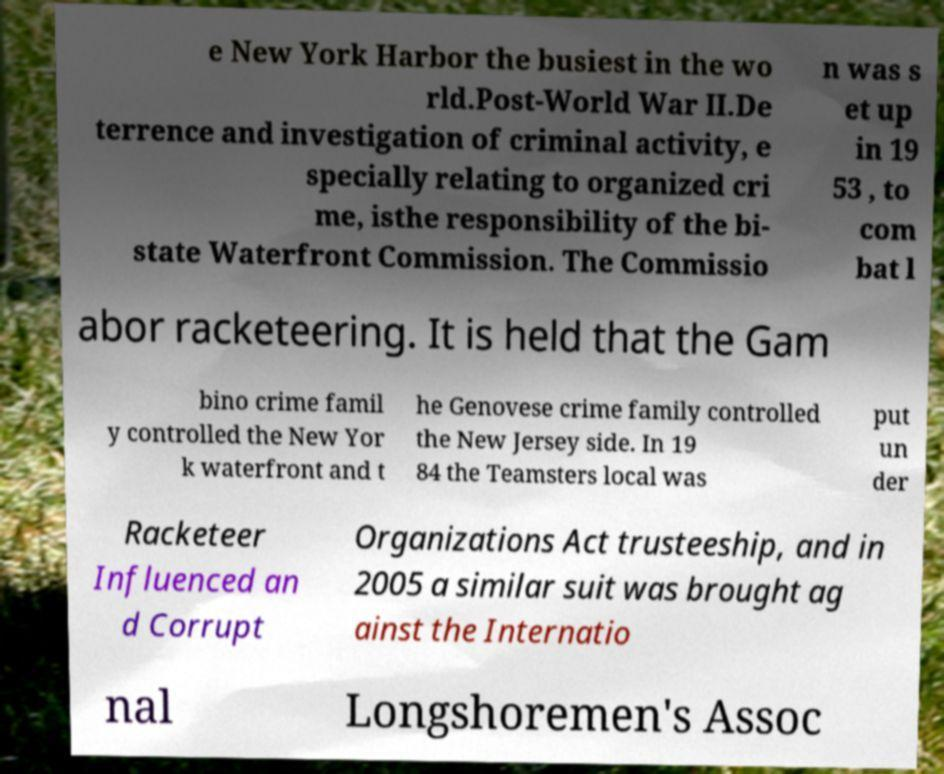Please read and relay the text visible in this image. What does it say? e New York Harbor the busiest in the wo rld.Post-World War II.De terrence and investigation of criminal activity, e specially relating to organized cri me, isthe responsibility of the bi- state Waterfront Commission. The Commissio n was s et up in 19 53 , to com bat l abor racketeering. It is held that the Gam bino crime famil y controlled the New Yor k waterfront and t he Genovese crime family controlled the New Jersey side. In 19 84 the Teamsters local was put un der Racketeer Influenced an d Corrupt Organizations Act trusteeship, and in 2005 a similar suit was brought ag ainst the Internatio nal Longshoremen's Assoc 